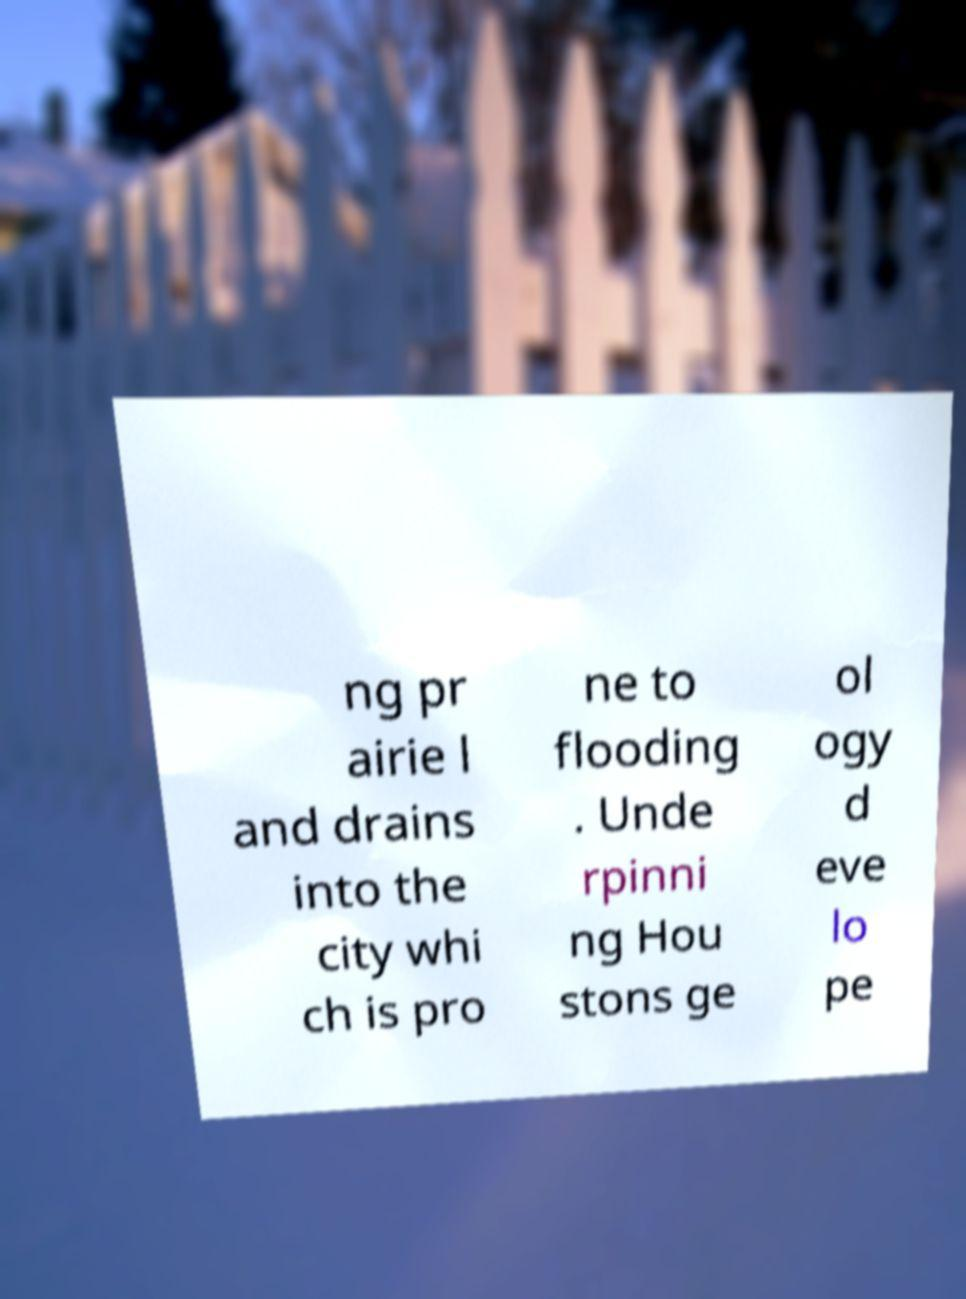What messages or text are displayed in this image? I need them in a readable, typed format. ng pr airie l and drains into the city whi ch is pro ne to flooding . Unde rpinni ng Hou stons ge ol ogy d eve lo pe 